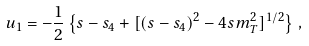Convert formula to latex. <formula><loc_0><loc_0><loc_500><loc_500>u _ { 1 } = - \frac { 1 } { 2 } \left \{ s - s _ { 4 } + [ ( s - s _ { 4 } ) ^ { 2 } - 4 s m _ { T } ^ { 2 } ] ^ { 1 / 2 } \right \} \, ,</formula> 